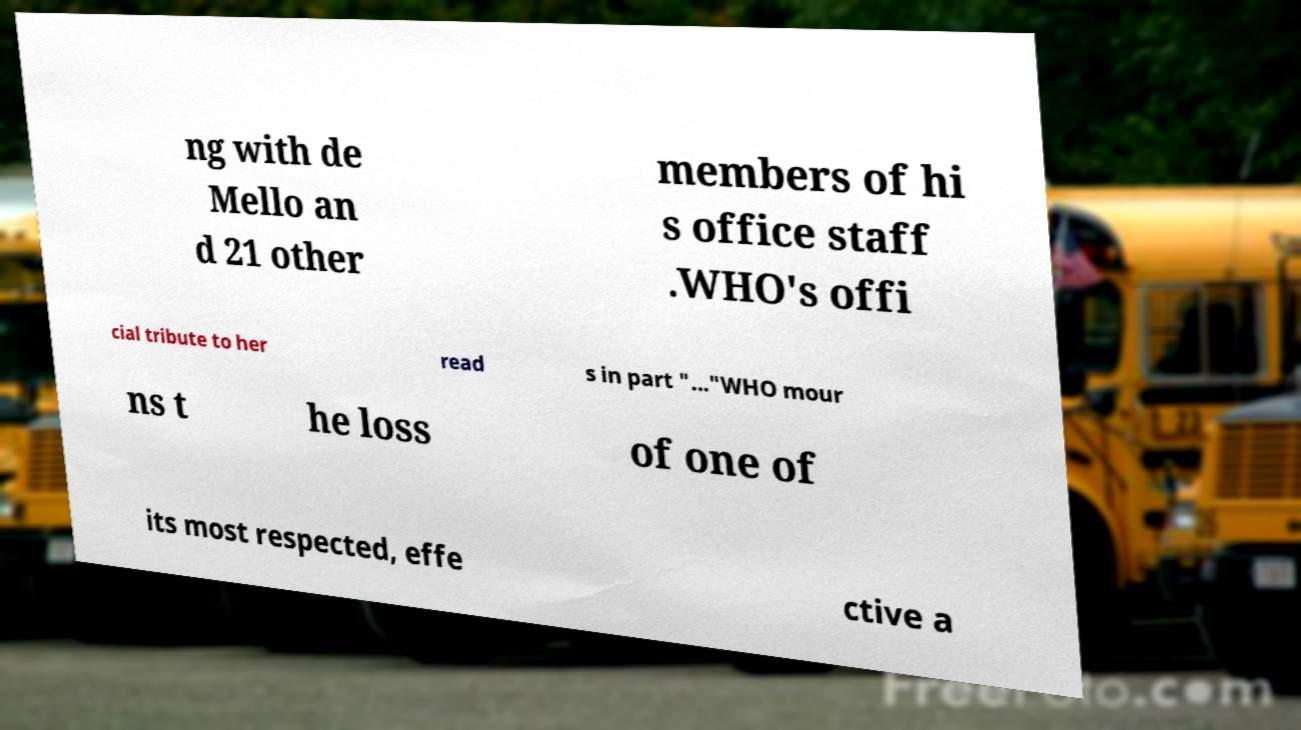Could you assist in decoding the text presented in this image and type it out clearly? ng with de Mello an d 21 other members of hi s office staff .WHO's offi cial tribute to her read s in part "..."WHO mour ns t he loss of one of its most respected, effe ctive a 